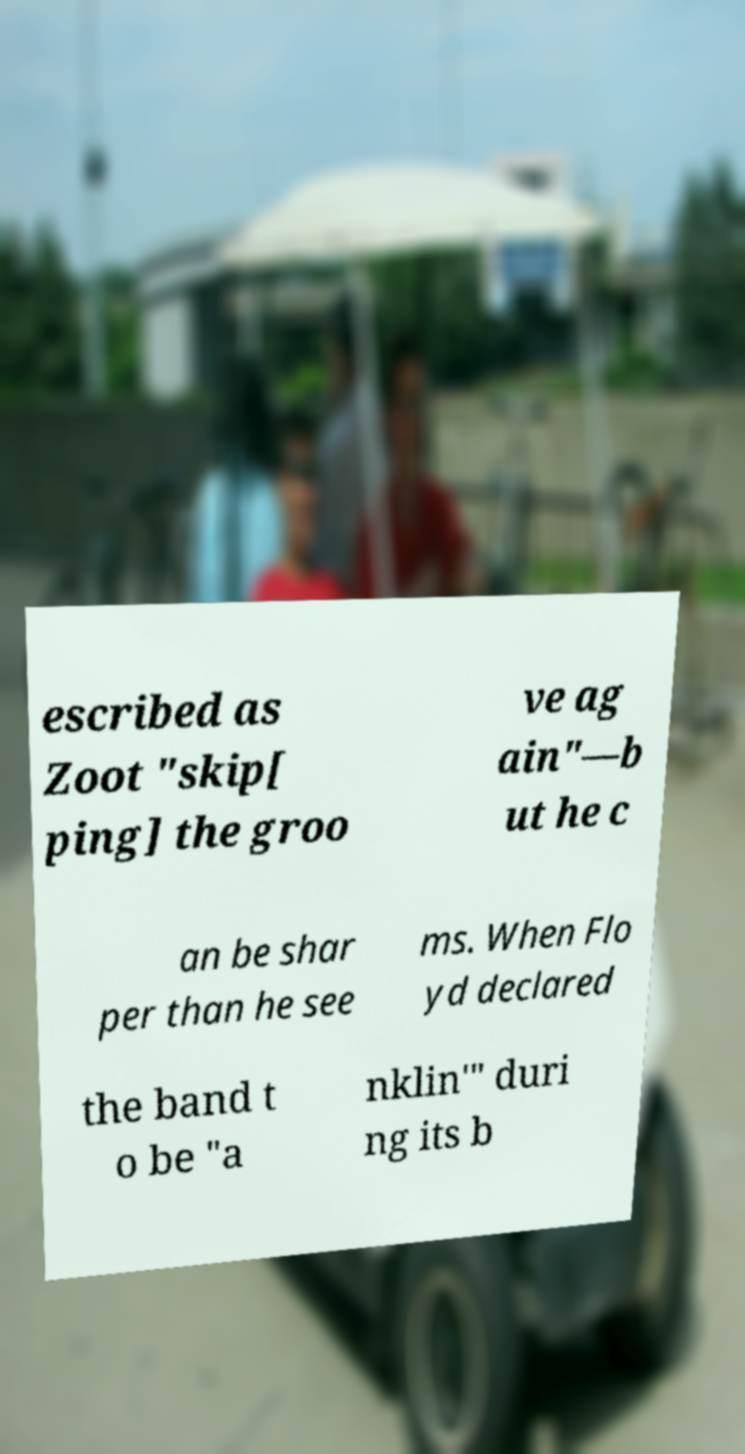Could you extract and type out the text from this image? escribed as Zoot "skip[ ping] the groo ve ag ain"—b ut he c an be shar per than he see ms. When Flo yd declared the band t o be "a nklin'" duri ng its b 